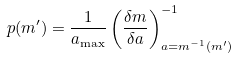Convert formula to latex. <formula><loc_0><loc_0><loc_500><loc_500>p ( m ^ { \prime } ) = \frac { 1 } { a _ { \max } } \left ( \frac { \delta m } { \delta a } \right ) _ { a = m ^ { - 1 } ( m ^ { \prime } ) } ^ { - 1 }</formula> 